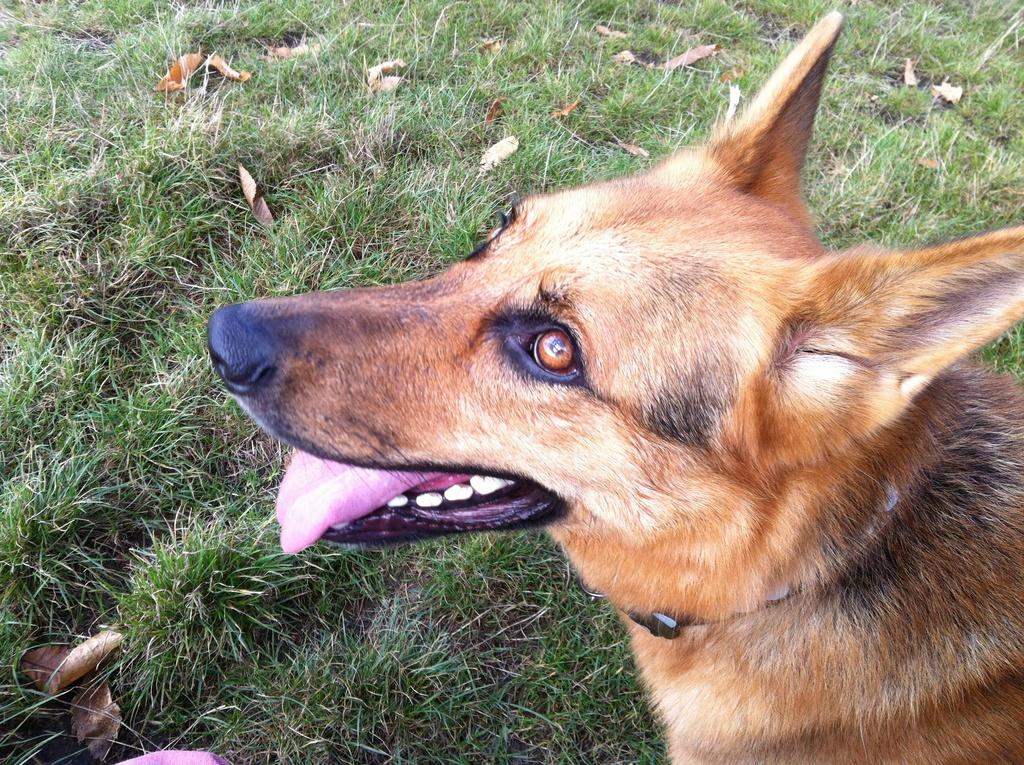What is the main subject in the foreground of the image? There is a dog in the foreground of the image. What type of terrain is visible at the bottom of the image? There is grass at the bottom of the image. What additional elements can be seen in the image? Dry leaves are present in the image. How many friends are holding pies in the image? There are no friends or pies present in the image; it features a dog and dry leaves on grass. 